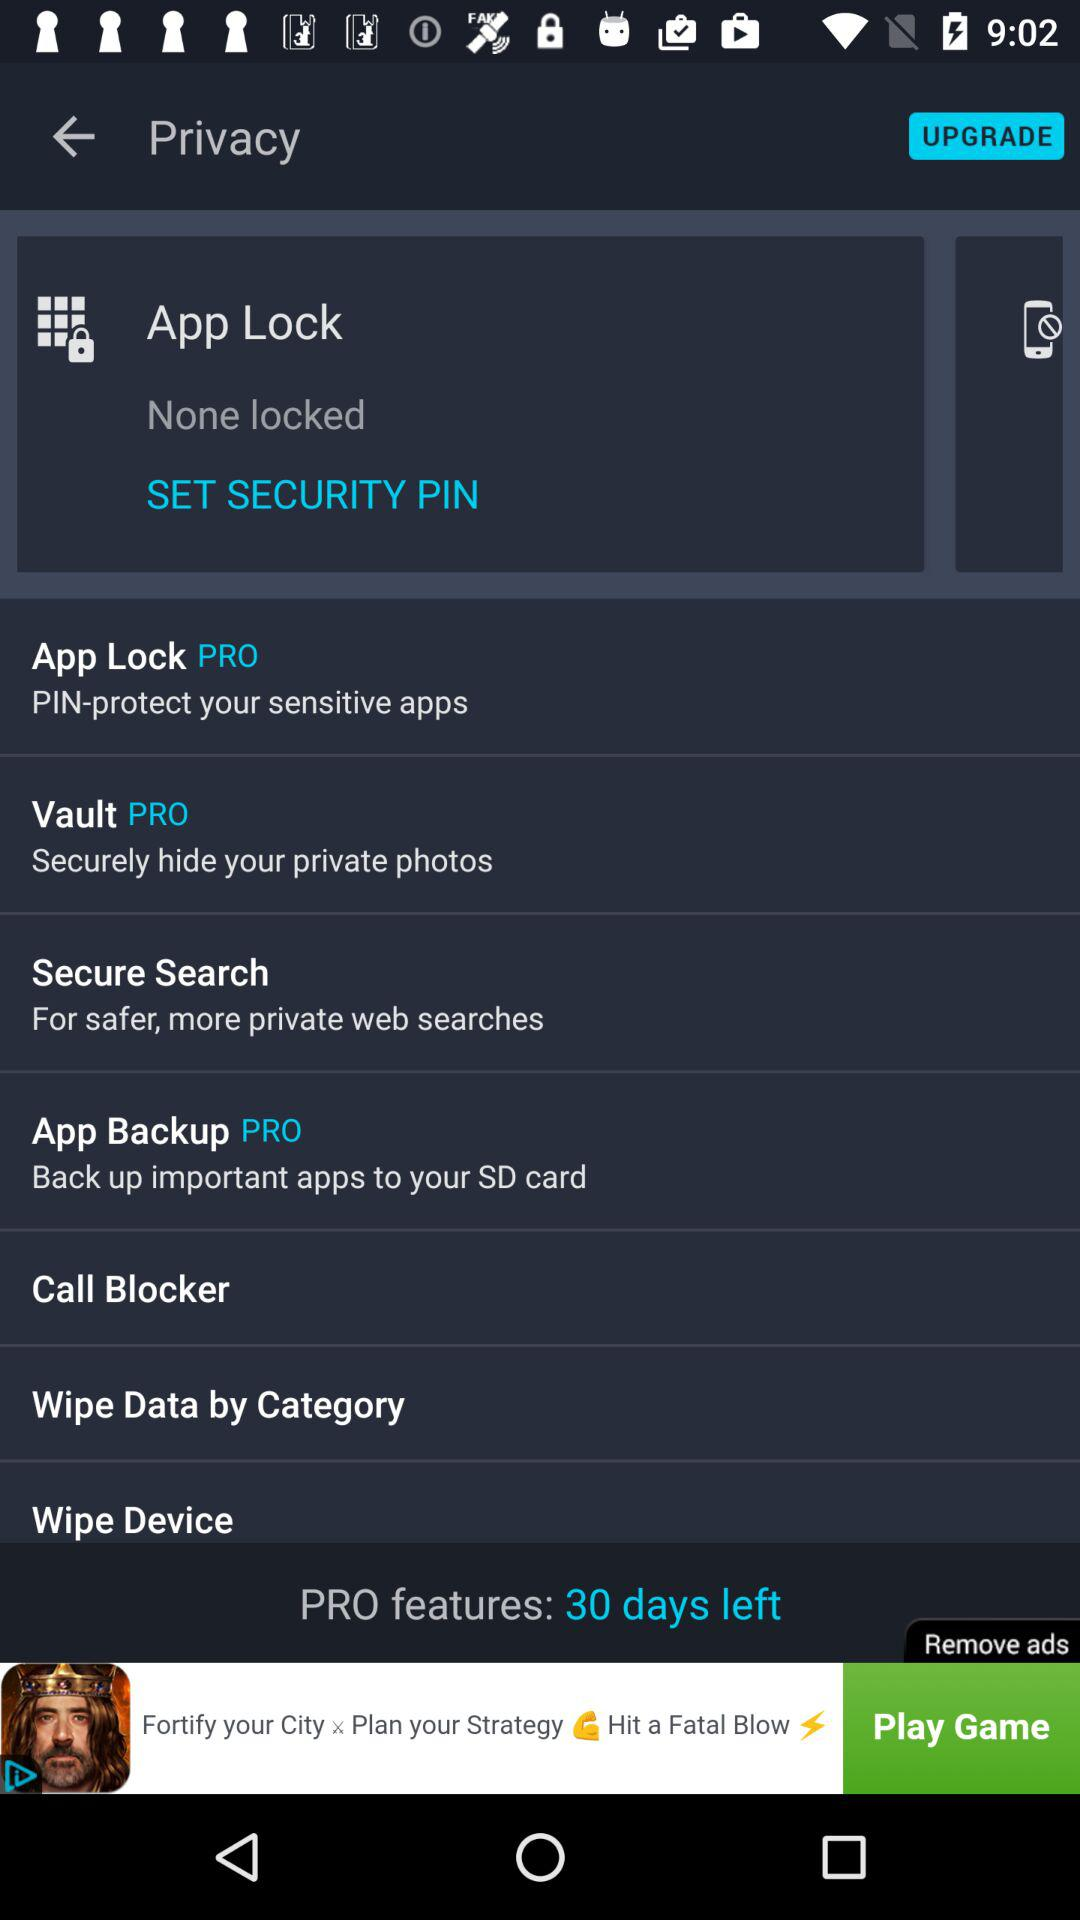How many features are available in the free version?
Answer the question using a single word or phrase. 4 